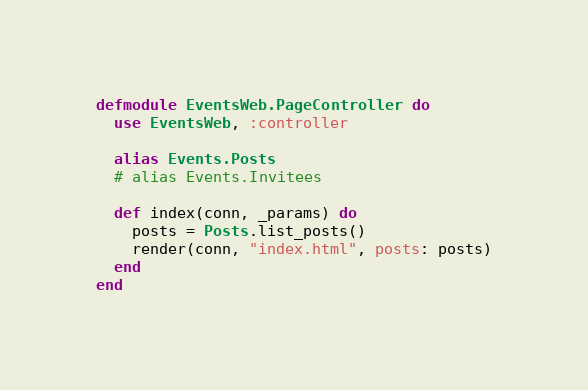Convert code to text. <code><loc_0><loc_0><loc_500><loc_500><_Elixir_>defmodule EventsWeb.PageController do
  use EventsWeb, :controller

  alias Events.Posts
  # alias Events.Invitees

  def index(conn, _params) do
    posts = Posts.list_posts()
    render(conn, "index.html", posts: posts)
  end
end
</code> 